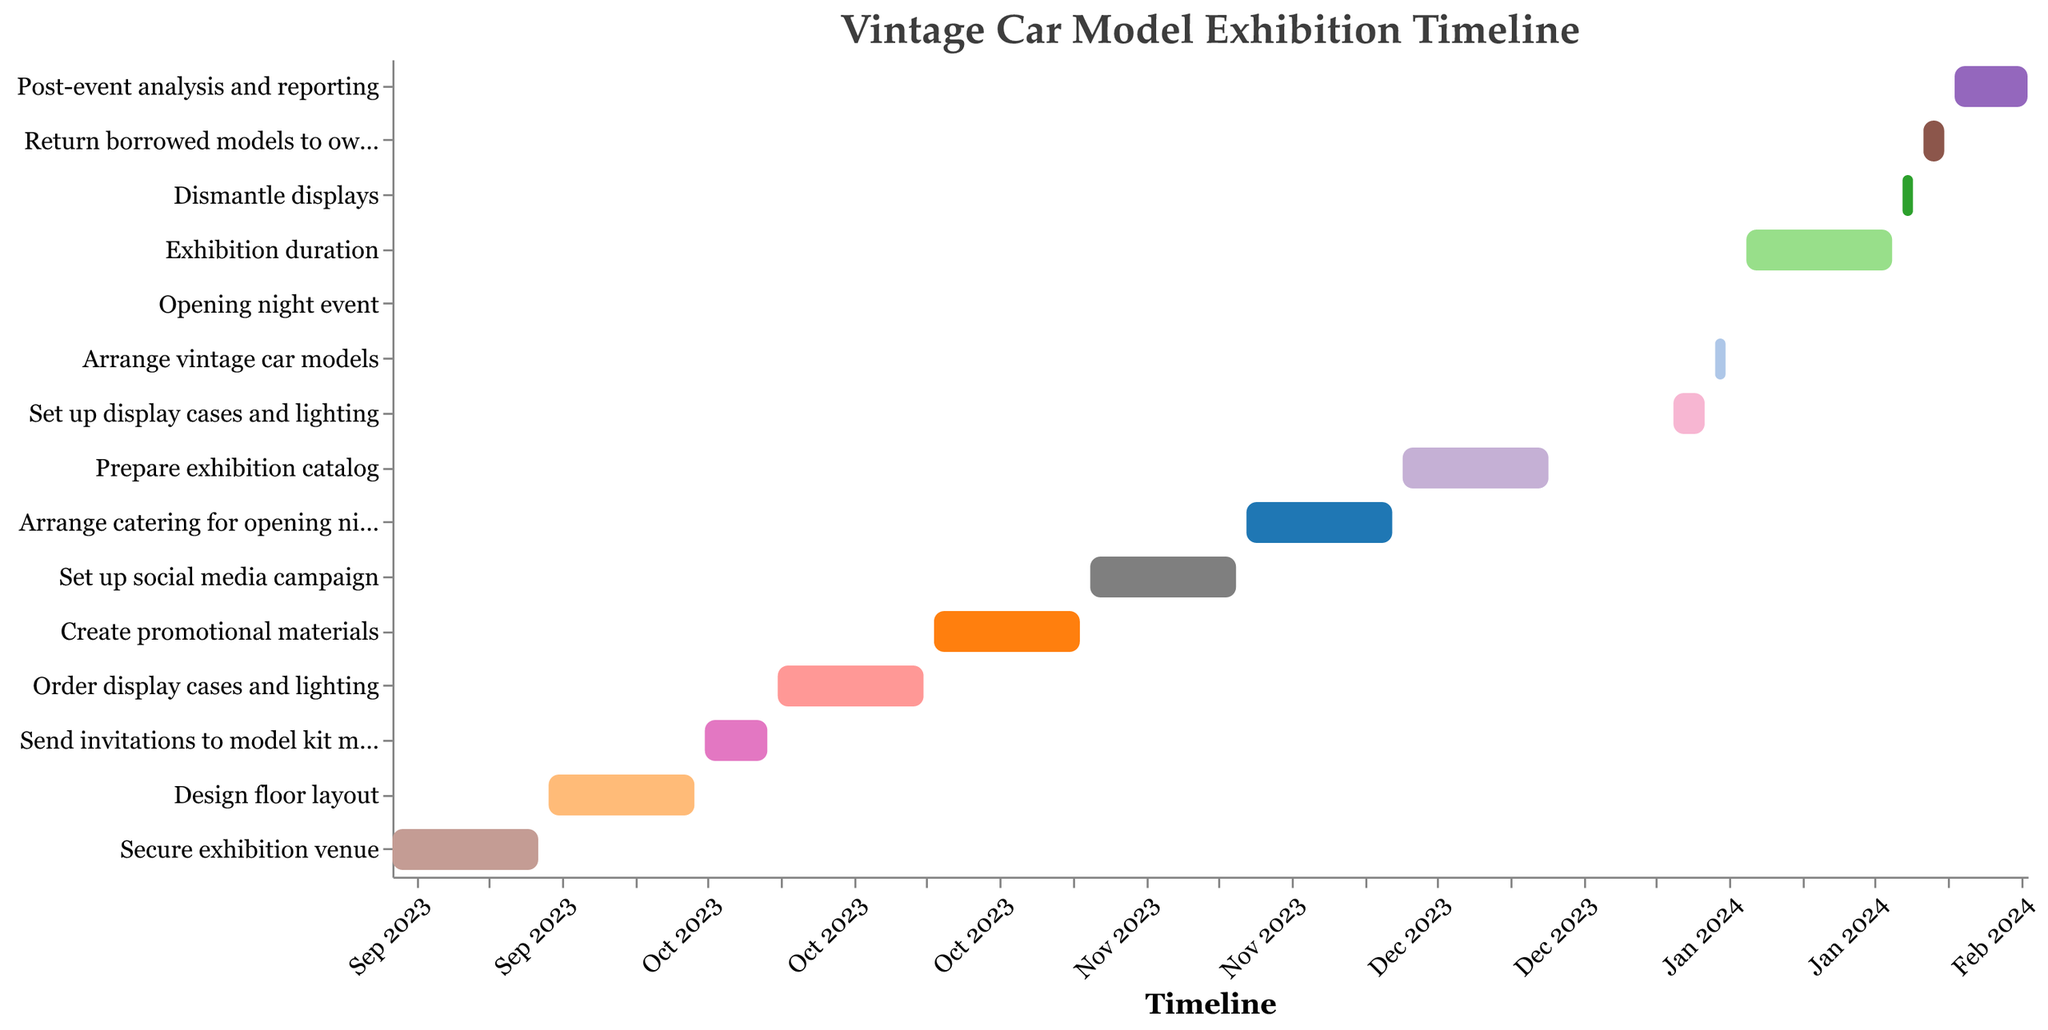What is the title of the figure? The title is displayed at the top of the figure, indicating the overall subject of the chart, which in this case is "Vintage Car Model Exhibition Timeline".
Answer: Vintage Car Model Exhibition Timeline When does the task of "Order display cases and lighting" start and end? Referring to the color-coded bar for this task, the tooltip or the axes can show the starting and ending dates. This task starts on 2023-10-08 and ends on 2023-10-22.
Answer: 2023-10-08 to 2023-10-22 Which task follows immediately after "Design floor layout"? By examining the timeline, the next task bar directly after "Design floor layout" is "Send invitations to model kit manufacturers".
Answer: Send invitations to model kit manufacturers How long is the exhibition duration in days? The length of the exhibition duration is found by subtracting the start date (2024-01-09) from the end date (2024-01-23). This results in 14 days.
Answer: 14 days What is the time gap between the end of "Prepare exhibition catalog" and the start of "Set up display cases and lighting"? "Prepare exhibition catalog" ends on 2023-12-21, and "Set up display cases and lighting" starts on 2024-01-02. The time gap between these two tasks is 12 days.
Answer: 12 days Which tasks are scheduled to be performed during the month of October 2023? Checking the timeline for October 2023, the tasks falling within this month are "Send invitations to model kit manufacturers" and "Order display cases and lighting".
Answer: Send invitations to model kit manufacturers, Order display cases and lighting Comparing "Secure exhibition venue" and "Prepare exhibition catalog", which task has a longer duration? "Secure exhibition venue" spans from 2023-09-01 to 2023-09-15, totaling 15 days. "Prepare exhibition catalog" runs from 2023-12-07 to 2023-12-21, totaling 15 days as well. Both tasks have the same duration of 15 days.
Answer: Both are equal What are the tasks involved in setting up the exhibition from January 2, 2024, to January 8, 2024? The tasks within this timeline are "Set up display cases and lighting" (from 2024-01-02 to 2024-01-05), "Arrange vintage car models" (from 2024-01-06 to 2024-01-07), and "Opening night event" (on 2024-01-08).
Answer: Set up display cases and lighting, Arrange vintage car models, Opening night event Which task takes the longest time to complete? By comparing the duration of each task using the bars, "Post-event analysis and reporting" takes the longest, spanning from 2024-01-29 to 2024-02-05, resulting in 8 days.
Answer: Post-event analysis and reporting 